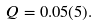Convert formula to latex. <formula><loc_0><loc_0><loc_500><loc_500>Q = 0 . 0 5 ( 5 ) .</formula> 